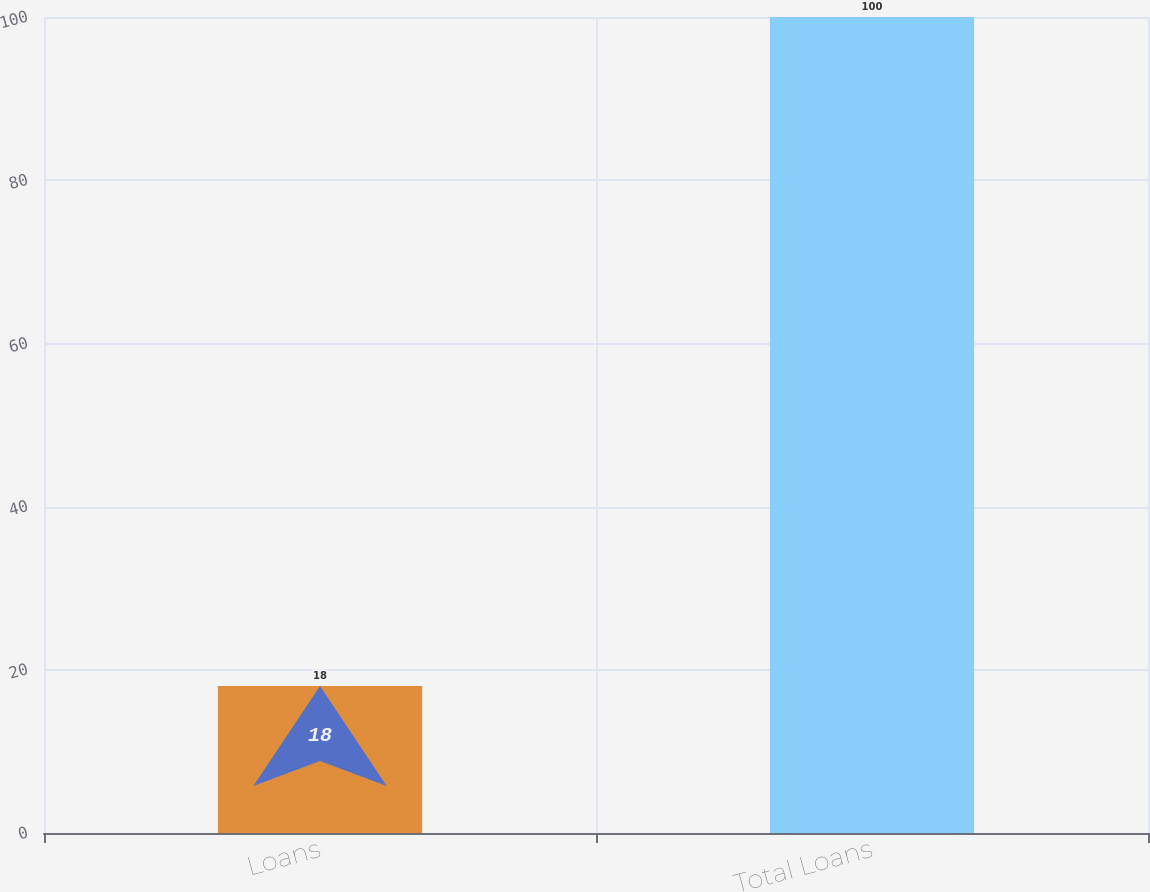Convert chart to OTSL. <chart><loc_0><loc_0><loc_500><loc_500><bar_chart><fcel>Loans<fcel>Total Loans<nl><fcel>18<fcel>100<nl></chart> 